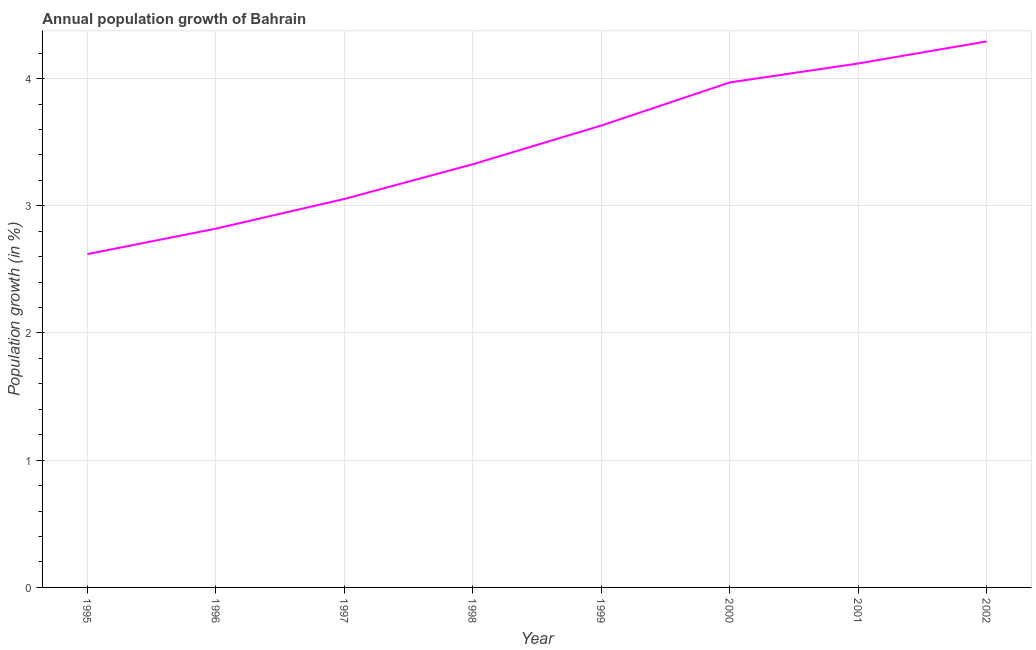What is the population growth in 2002?
Your answer should be compact. 4.29. Across all years, what is the maximum population growth?
Provide a succinct answer. 4.29. Across all years, what is the minimum population growth?
Your response must be concise. 2.62. What is the sum of the population growth?
Provide a short and direct response. 27.83. What is the difference between the population growth in 1997 and 2002?
Keep it short and to the point. -1.24. What is the average population growth per year?
Your answer should be compact. 3.48. What is the median population growth?
Make the answer very short. 3.48. In how many years, is the population growth greater than 2.4 %?
Your answer should be very brief. 8. What is the ratio of the population growth in 1997 to that in 2000?
Your answer should be very brief. 0.77. Is the population growth in 1995 less than that in 2002?
Give a very brief answer. Yes. What is the difference between the highest and the second highest population growth?
Offer a very short reply. 0.17. What is the difference between the highest and the lowest population growth?
Provide a succinct answer. 1.67. In how many years, is the population growth greater than the average population growth taken over all years?
Provide a succinct answer. 4. Does the graph contain grids?
Your answer should be very brief. Yes. What is the title of the graph?
Offer a terse response. Annual population growth of Bahrain. What is the label or title of the Y-axis?
Your answer should be very brief. Population growth (in %). What is the Population growth (in %) of 1995?
Offer a terse response. 2.62. What is the Population growth (in %) in 1996?
Provide a short and direct response. 2.82. What is the Population growth (in %) in 1997?
Offer a terse response. 3.05. What is the Population growth (in %) in 1998?
Your response must be concise. 3.33. What is the Population growth (in %) of 1999?
Ensure brevity in your answer.  3.63. What is the Population growth (in %) in 2000?
Offer a terse response. 3.97. What is the Population growth (in %) of 2001?
Give a very brief answer. 4.12. What is the Population growth (in %) of 2002?
Ensure brevity in your answer.  4.29. What is the difference between the Population growth (in %) in 1995 and 1996?
Offer a very short reply. -0.2. What is the difference between the Population growth (in %) in 1995 and 1997?
Provide a short and direct response. -0.43. What is the difference between the Population growth (in %) in 1995 and 1998?
Offer a terse response. -0.71. What is the difference between the Population growth (in %) in 1995 and 1999?
Give a very brief answer. -1.01. What is the difference between the Population growth (in %) in 1995 and 2000?
Your response must be concise. -1.35. What is the difference between the Population growth (in %) in 1995 and 2001?
Keep it short and to the point. -1.5. What is the difference between the Population growth (in %) in 1995 and 2002?
Provide a short and direct response. -1.67. What is the difference between the Population growth (in %) in 1996 and 1997?
Give a very brief answer. -0.23. What is the difference between the Population growth (in %) in 1996 and 1998?
Keep it short and to the point. -0.51. What is the difference between the Population growth (in %) in 1996 and 1999?
Your answer should be very brief. -0.81. What is the difference between the Population growth (in %) in 1996 and 2000?
Provide a succinct answer. -1.15. What is the difference between the Population growth (in %) in 1996 and 2001?
Your answer should be very brief. -1.3. What is the difference between the Population growth (in %) in 1996 and 2002?
Your answer should be compact. -1.47. What is the difference between the Population growth (in %) in 1997 and 1998?
Make the answer very short. -0.27. What is the difference between the Population growth (in %) in 1997 and 1999?
Your response must be concise. -0.58. What is the difference between the Population growth (in %) in 1997 and 2000?
Your answer should be very brief. -0.92. What is the difference between the Population growth (in %) in 1997 and 2001?
Your answer should be compact. -1.07. What is the difference between the Population growth (in %) in 1997 and 2002?
Keep it short and to the point. -1.24. What is the difference between the Population growth (in %) in 1998 and 1999?
Provide a short and direct response. -0.3. What is the difference between the Population growth (in %) in 1998 and 2000?
Keep it short and to the point. -0.64. What is the difference between the Population growth (in %) in 1998 and 2001?
Give a very brief answer. -0.79. What is the difference between the Population growth (in %) in 1998 and 2002?
Offer a very short reply. -0.97. What is the difference between the Population growth (in %) in 1999 and 2000?
Your answer should be very brief. -0.34. What is the difference between the Population growth (in %) in 1999 and 2001?
Ensure brevity in your answer.  -0.49. What is the difference between the Population growth (in %) in 1999 and 2002?
Your response must be concise. -0.66. What is the difference between the Population growth (in %) in 2000 and 2001?
Give a very brief answer. -0.15. What is the difference between the Population growth (in %) in 2000 and 2002?
Make the answer very short. -0.32. What is the difference between the Population growth (in %) in 2001 and 2002?
Make the answer very short. -0.17. What is the ratio of the Population growth (in %) in 1995 to that in 1996?
Provide a short and direct response. 0.93. What is the ratio of the Population growth (in %) in 1995 to that in 1997?
Offer a very short reply. 0.86. What is the ratio of the Population growth (in %) in 1995 to that in 1998?
Your answer should be very brief. 0.79. What is the ratio of the Population growth (in %) in 1995 to that in 1999?
Ensure brevity in your answer.  0.72. What is the ratio of the Population growth (in %) in 1995 to that in 2000?
Your answer should be compact. 0.66. What is the ratio of the Population growth (in %) in 1995 to that in 2001?
Keep it short and to the point. 0.64. What is the ratio of the Population growth (in %) in 1995 to that in 2002?
Give a very brief answer. 0.61. What is the ratio of the Population growth (in %) in 1996 to that in 1997?
Make the answer very short. 0.92. What is the ratio of the Population growth (in %) in 1996 to that in 1998?
Your response must be concise. 0.85. What is the ratio of the Population growth (in %) in 1996 to that in 1999?
Your response must be concise. 0.78. What is the ratio of the Population growth (in %) in 1996 to that in 2000?
Keep it short and to the point. 0.71. What is the ratio of the Population growth (in %) in 1996 to that in 2001?
Your answer should be compact. 0.69. What is the ratio of the Population growth (in %) in 1996 to that in 2002?
Ensure brevity in your answer.  0.66. What is the ratio of the Population growth (in %) in 1997 to that in 1998?
Give a very brief answer. 0.92. What is the ratio of the Population growth (in %) in 1997 to that in 1999?
Your response must be concise. 0.84. What is the ratio of the Population growth (in %) in 1997 to that in 2000?
Your answer should be compact. 0.77. What is the ratio of the Population growth (in %) in 1997 to that in 2001?
Offer a terse response. 0.74. What is the ratio of the Population growth (in %) in 1997 to that in 2002?
Your answer should be very brief. 0.71. What is the ratio of the Population growth (in %) in 1998 to that in 1999?
Offer a very short reply. 0.92. What is the ratio of the Population growth (in %) in 1998 to that in 2000?
Make the answer very short. 0.84. What is the ratio of the Population growth (in %) in 1998 to that in 2001?
Ensure brevity in your answer.  0.81. What is the ratio of the Population growth (in %) in 1998 to that in 2002?
Offer a very short reply. 0.78. What is the ratio of the Population growth (in %) in 1999 to that in 2000?
Ensure brevity in your answer.  0.92. What is the ratio of the Population growth (in %) in 1999 to that in 2001?
Offer a terse response. 0.88. What is the ratio of the Population growth (in %) in 1999 to that in 2002?
Keep it short and to the point. 0.85. What is the ratio of the Population growth (in %) in 2000 to that in 2002?
Give a very brief answer. 0.93. 